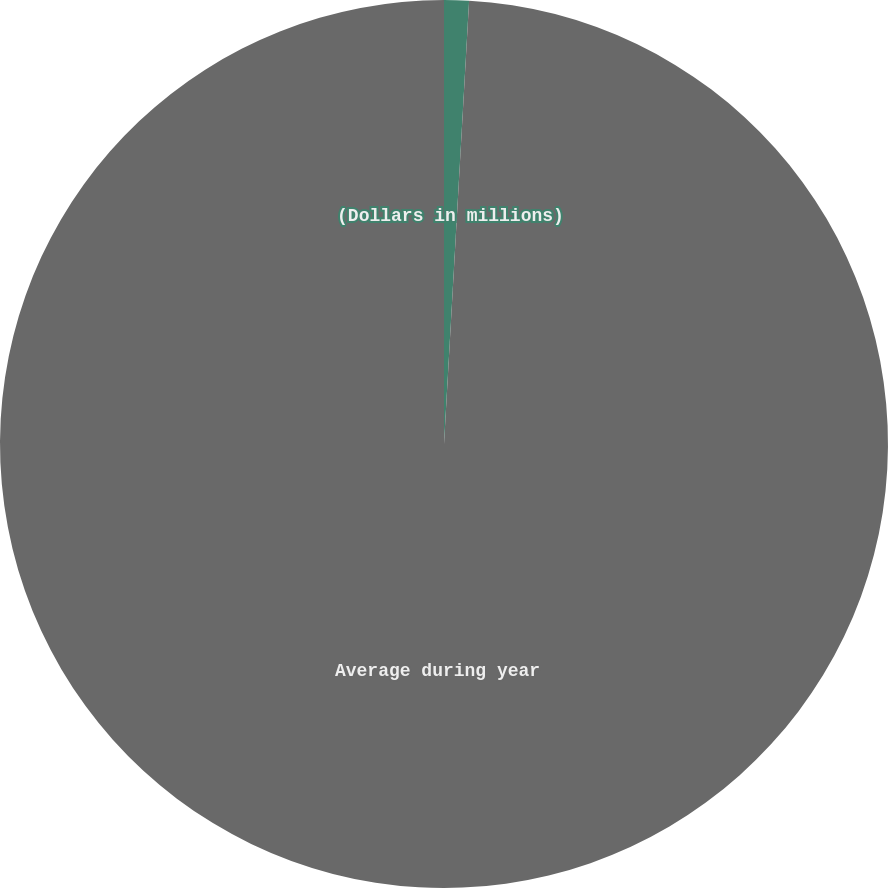Convert chart. <chart><loc_0><loc_0><loc_500><loc_500><pie_chart><fcel>(Dollars in millions)<fcel>Average during year<nl><fcel>0.9%<fcel>99.1%<nl></chart> 